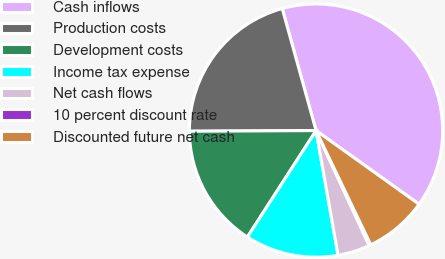<chart> <loc_0><loc_0><loc_500><loc_500><pie_chart><fcel>Cash inflows<fcel>Production costs<fcel>Development costs<fcel>Income tax expense<fcel>Net cash flows<fcel>10 percent discount rate<fcel>Discounted future net cash<nl><fcel>39.18%<fcel>20.78%<fcel>15.8%<fcel>11.9%<fcel>4.11%<fcel>0.22%<fcel>8.01%<nl></chart> 